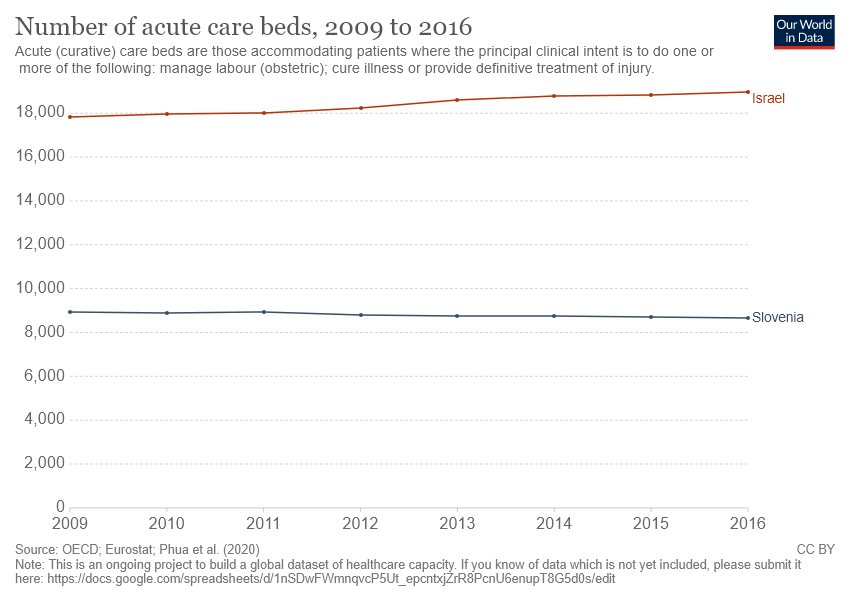Identify some key points in this picture. The graph compares the life expectancy of two countries, and the answer is Israel and Slovenia. In 2016, Israel had a higher number of acute care beds than Slovenia. 